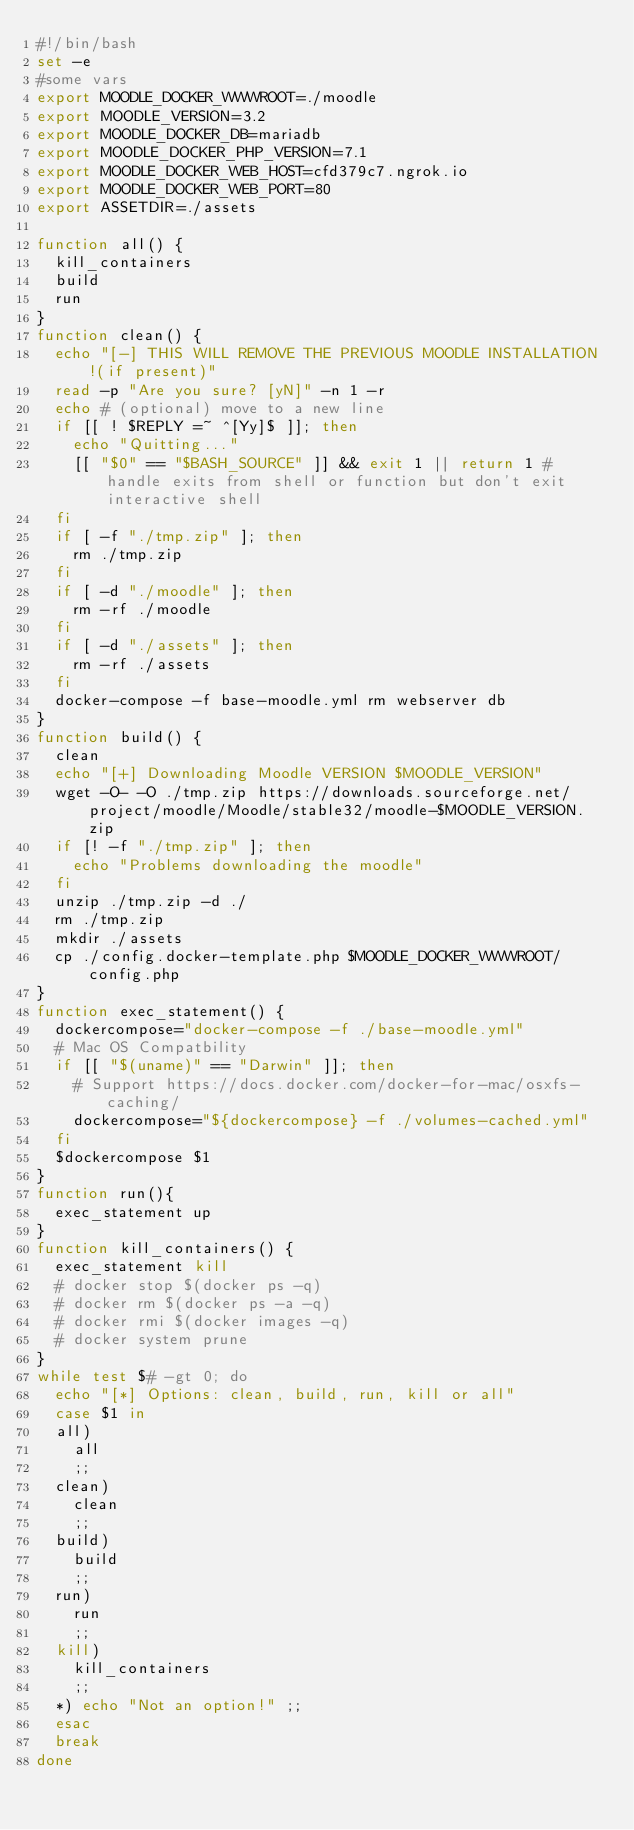Convert code to text. <code><loc_0><loc_0><loc_500><loc_500><_Bash_>#!/bin/bash
set -e
#some vars
export MOODLE_DOCKER_WWWROOT=./moodle
export MOODLE_VERSION=3.2
export MOODLE_DOCKER_DB=mariadb
export MOODLE_DOCKER_PHP_VERSION=7.1
export MOODLE_DOCKER_WEB_HOST=cfd379c7.ngrok.io
export MOODLE_DOCKER_WEB_PORT=80
export ASSETDIR=./assets

function all() {
	kill_containers
	build
	run
}
function clean() {
	echo "[-] THIS WILL REMOVE THE PREVIOUS MOODLE INSTALLATION!(if present)"
	read -p "Are you sure? [yN]" -n 1 -r
	echo # (optional) move to a new line
	if [[ ! $REPLY =~ ^[Yy]$ ]]; then
		echo "Quitting..."
		[[ "$0" == "$BASH_SOURCE" ]] && exit 1 || return 1 # handle exits from shell or function but don't exit interactive shell
	fi
	if [ -f "./tmp.zip" ]; then
		rm ./tmp.zip
	fi
	if [ -d "./moodle" ]; then
		rm -rf ./moodle
	fi
	if [ -d "./assets" ]; then
		rm -rf ./assets
	fi
	docker-compose -f base-moodle.yml rm webserver db
}
function build() {
	clean
	echo "[+] Downloading Moodle VERSION $MOODLE_VERSION"
	wget -O- -O ./tmp.zip https://downloads.sourceforge.net/project/moodle/Moodle/stable32/moodle-$MOODLE_VERSION.zip
	if [! -f "./tmp.zip" ]; then
		echo "Problems downloading the moodle"
	fi
	unzip ./tmp.zip -d ./
	rm ./tmp.zip
	mkdir ./assets
	cp ./config.docker-template.php $MOODLE_DOCKER_WWWROOT/config.php
}
function exec_statement() {
	dockercompose="docker-compose -f ./base-moodle.yml"
	# Mac OS Compatbility
	if [[ "$(uname)" == "Darwin" ]]; then
		# Support https://docs.docker.com/docker-for-mac/osxfs-caching/
		dockercompose="${dockercompose} -f ./volumes-cached.yml"
	fi
	$dockercompose $1
}
function run(){
	exec_statement up
}
function kill_containers() {
	exec_statement kill
	# docker stop $(docker ps -q)
	# docker rm $(docker ps -a -q)
	# docker rmi $(docker images -q)
	# docker system prune
}
while test $# -gt 0; do
	echo "[*] Options: clean, build, run, kill or all"
	case $1 in
	all)
		all
		;;
	clean)
		clean
		;;
	build)
		build
		;;
	run)
		run
		;;
	kill)
		kill_containers
		;;
	*) echo "Not an option!" ;;
	esac
	break
done
</code> 